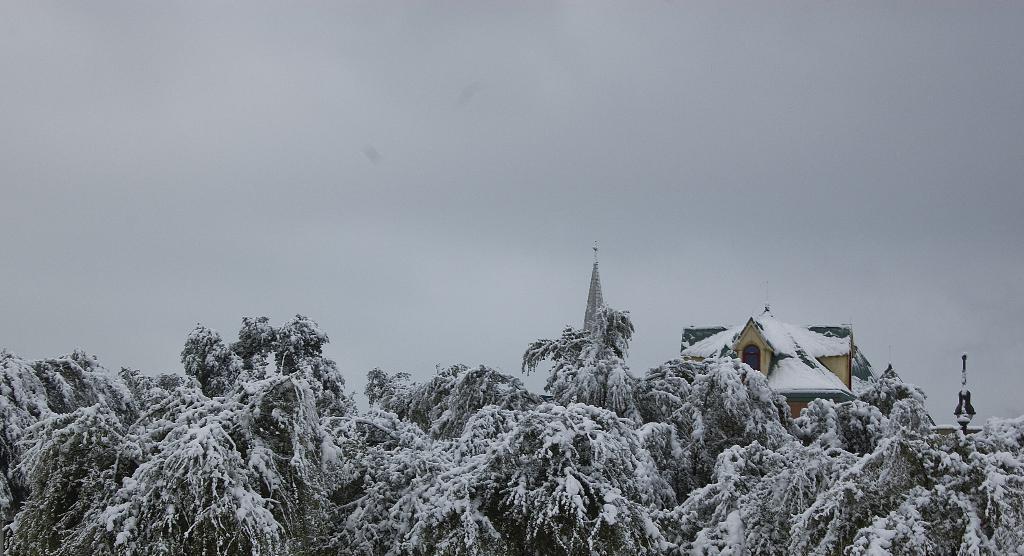How would you summarize this image in a sentence or two? In this image we can see some trees on which there is some snow and in the background of the image there is a house and top of the image there is cloudy sky. 